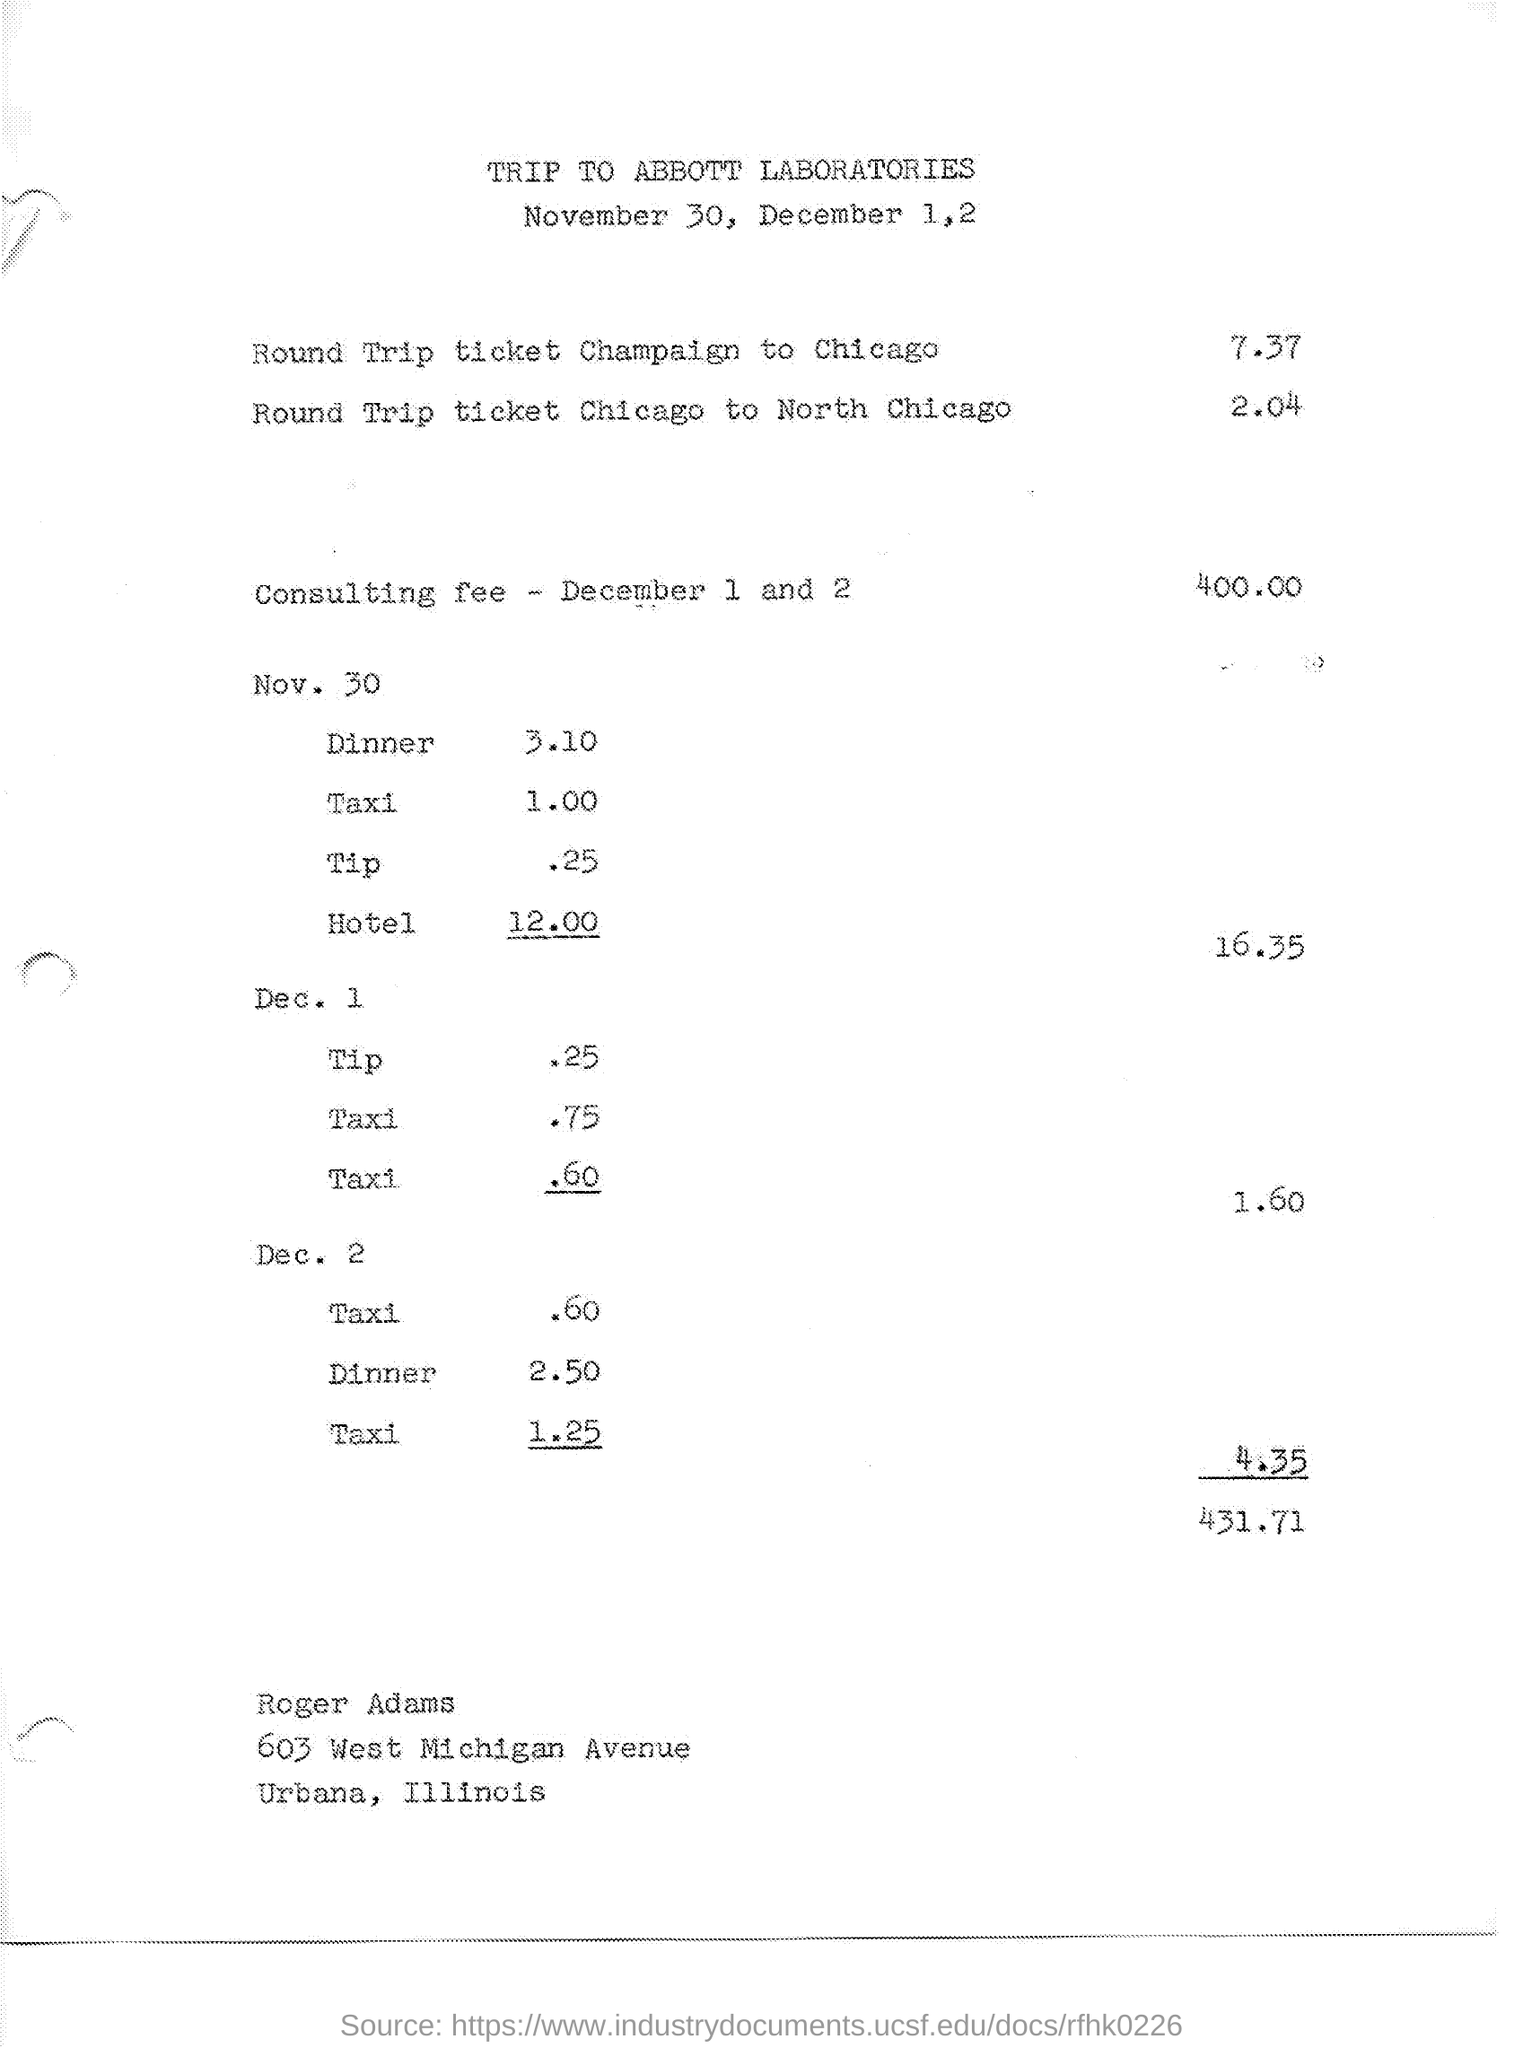What is the cost of round trip ticket champaign to chicago ?
Your answer should be very brief. 7.37. What is the cost of round trip ticket chicago to north chicago ?
Offer a terse response. 2.04. What is the consulting fee on december 1 and 2 ?
Your answer should be compact. 400.00. What is the cost of dinner on nov. 30 ?
Your answer should be very brief. 3.10. What is the cost of hotel on nov. 30 ?
Your answer should be compact. 12.00. What is the total expenses on nov. 30 ?
Keep it short and to the point. 16.35. What is the total expenses on dec. 1 ?
Your response must be concise. 1.60. What is the cost of taxi on dec. 2 ?
Give a very brief answer. .60. What  is the cost of dinner on dec. 2?
Offer a terse response. 2.50. What is the total expenses on dec. 2 ?
Make the answer very short. 4.35. 